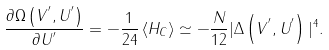Convert formula to latex. <formula><loc_0><loc_0><loc_500><loc_500>\frac { \partial \Omega \left ( V ^ { ^ { \prime } } , U ^ { ^ { \prime } } \right ) } { \partial U ^ { ^ { \prime } } } = - \frac { 1 } { 2 4 } \left < H _ { C } \right > \simeq - \frac { N } { 1 2 } | \Delta \left ( V ^ { ^ { \prime } } , U ^ { ^ { \prime } } \right ) | ^ { 4 } .</formula> 